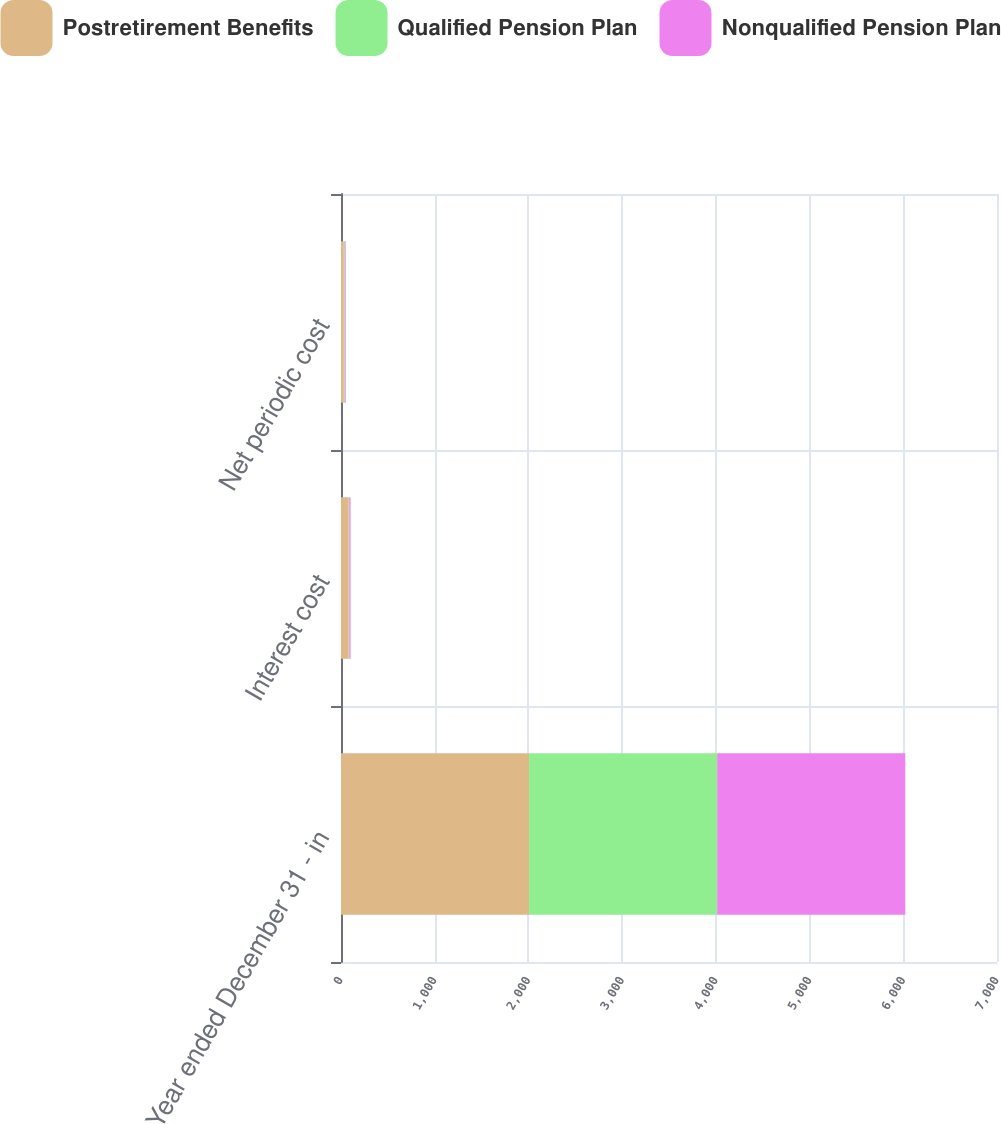Convert chart to OTSL. <chart><loc_0><loc_0><loc_500><loc_500><stacked_bar_chart><ecel><fcel>Year ended December 31 - in<fcel>Interest cost<fcel>Net periodic cost<nl><fcel>Postretirement Benefits<fcel>2007<fcel>82<fcel>30<nl><fcel>Qualified Pension Plan<fcel>2007<fcel>6<fcel>10<nl><fcel>Nonqualified Pension Plan<fcel>2007<fcel>14<fcel>10<nl></chart> 